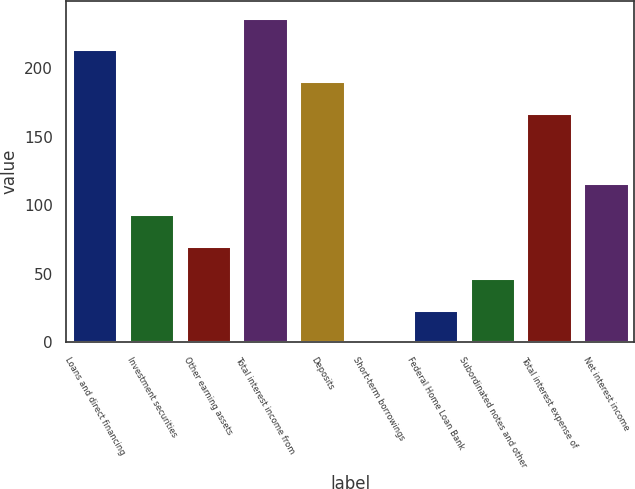Convert chart. <chart><loc_0><loc_0><loc_500><loc_500><bar_chart><fcel>Loans and direct financing<fcel>Investment securities<fcel>Other earning assets<fcel>Total interest income from<fcel>Deposits<fcel>Short-term borrowings<fcel>Federal Home Loan Bank<fcel>Subordinated notes and other<fcel>Total interest expense of<fcel>Net interest income<nl><fcel>213.84<fcel>93.28<fcel>70.11<fcel>237.01<fcel>190.67<fcel>0.6<fcel>23.77<fcel>46.94<fcel>167.5<fcel>116.45<nl></chart> 